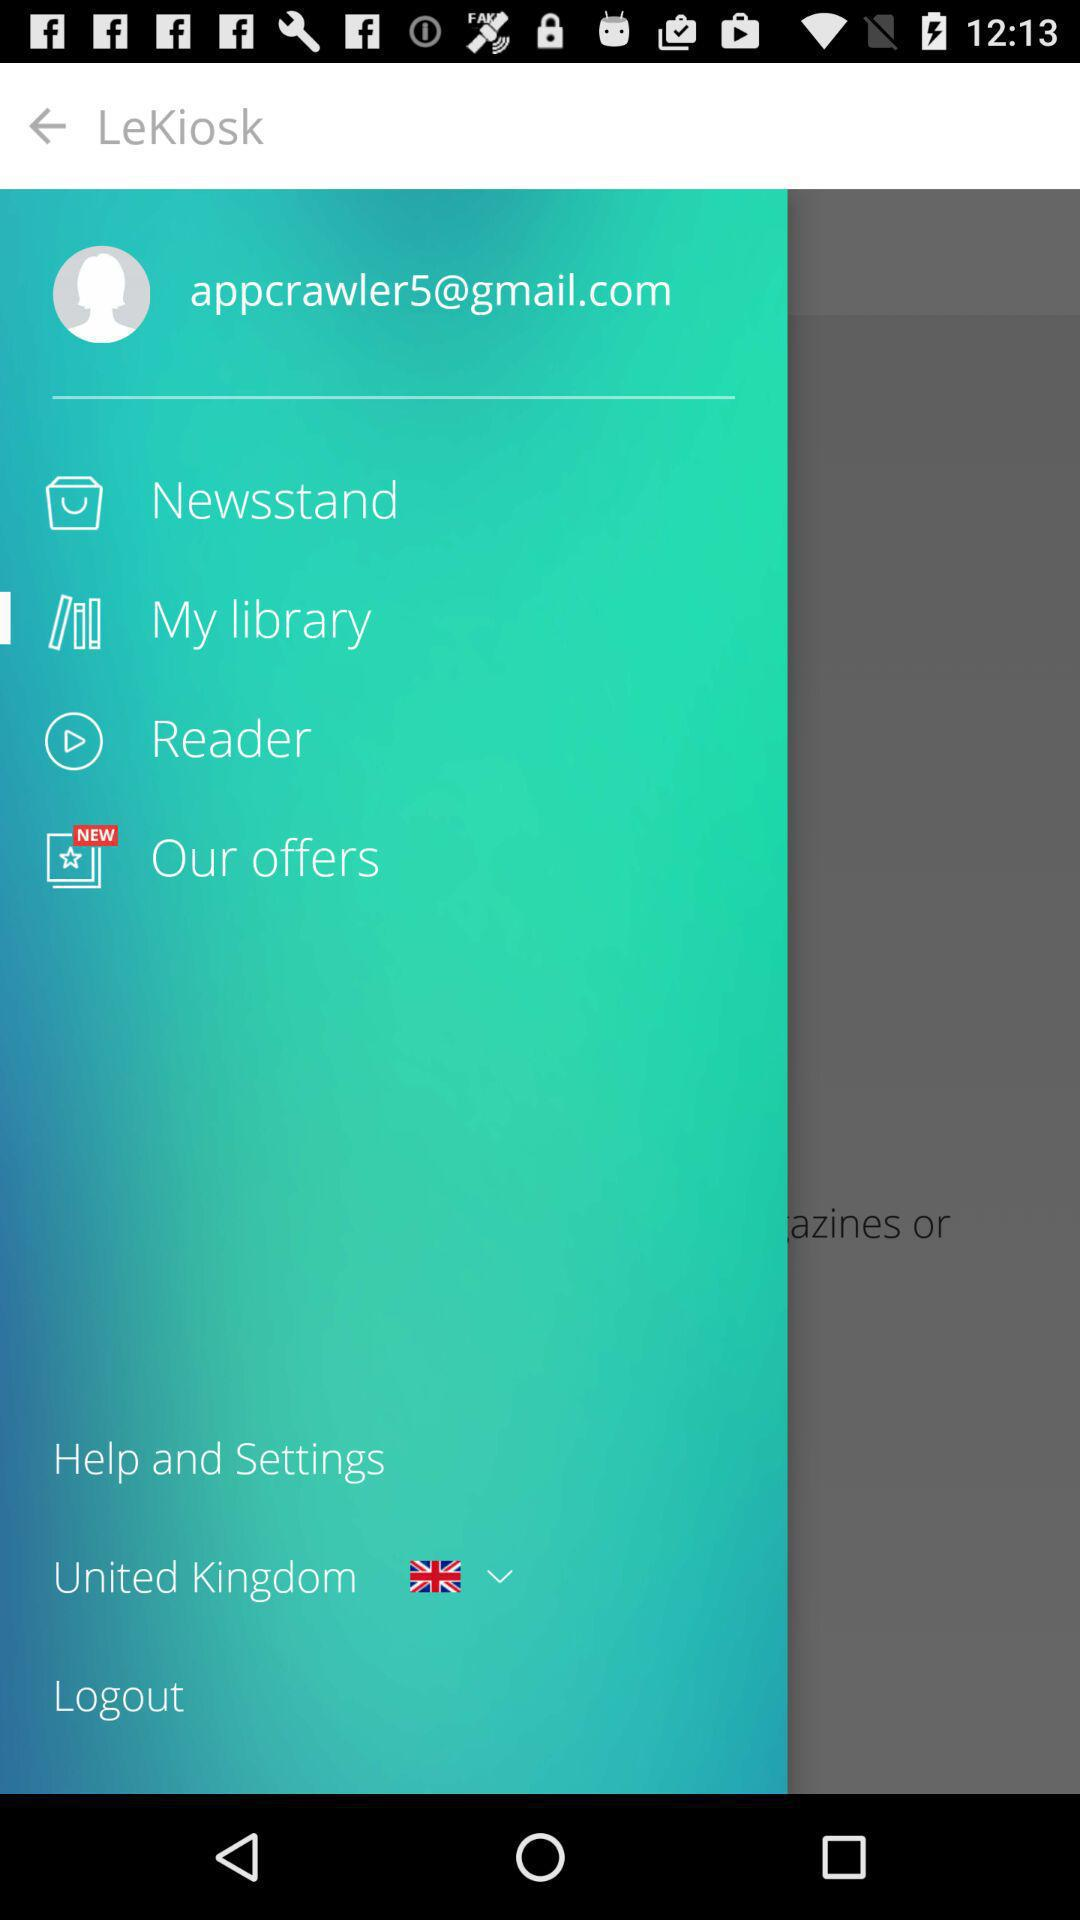What is the email address? The email address is appcrawler5@gmail.com. 